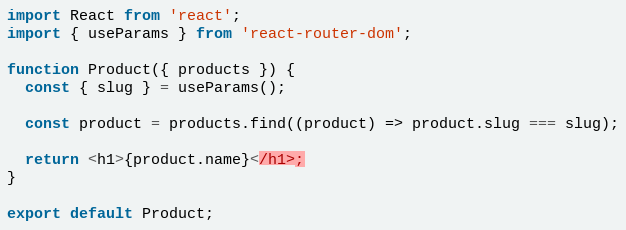Convert code to text. <code><loc_0><loc_0><loc_500><loc_500><_JavaScript_>import React from 'react';
import { useParams } from 'react-router-dom';

function Product({ products }) {
  const { slug } = useParams();

  const product = products.find((product) => product.slug === slug);

  return <h1>{product.name}</h1>;
}

export default Product;
</code> 